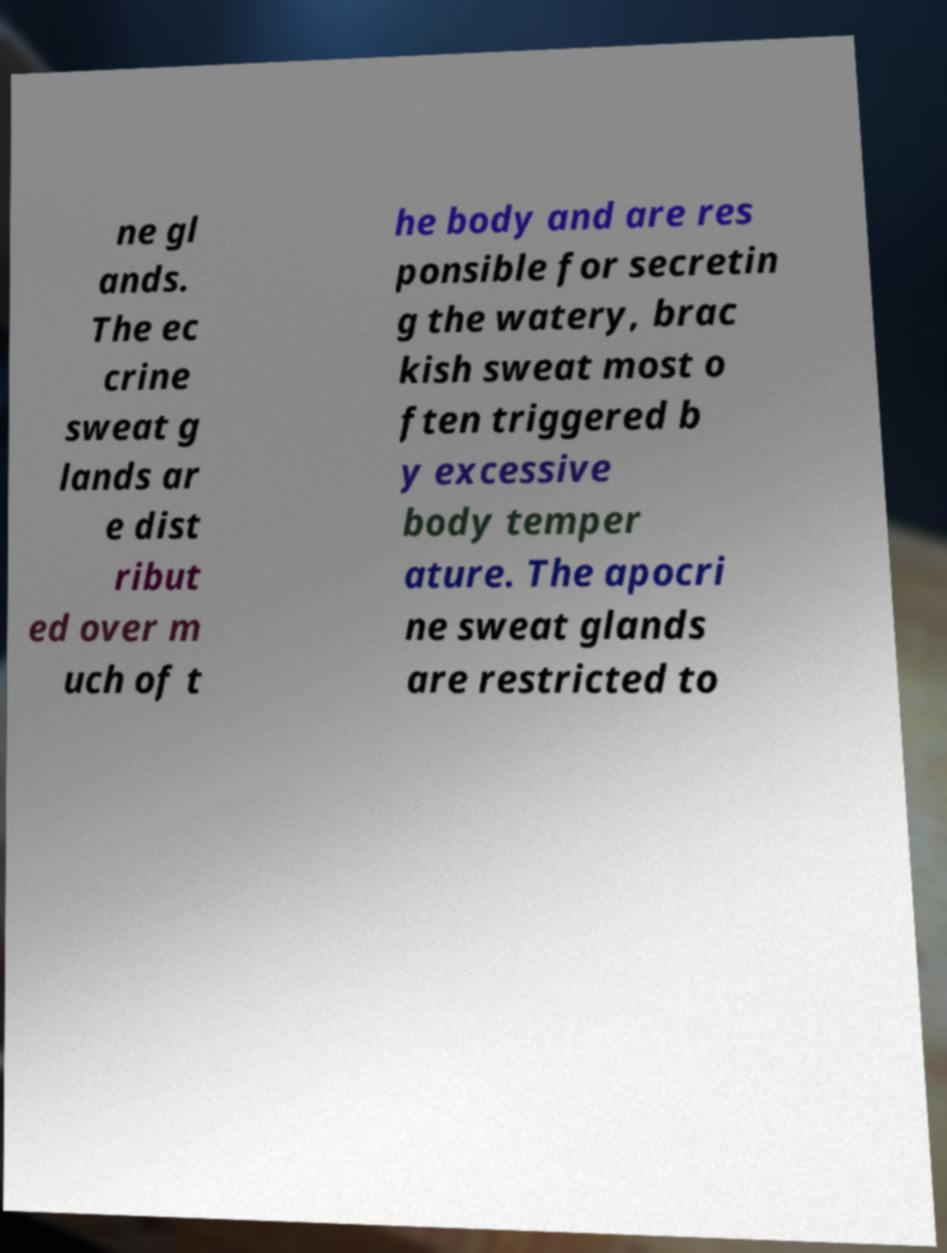What messages or text are displayed in this image? I need them in a readable, typed format. ne gl ands. The ec crine sweat g lands ar e dist ribut ed over m uch of t he body and are res ponsible for secretin g the watery, brac kish sweat most o ften triggered b y excessive body temper ature. The apocri ne sweat glands are restricted to 